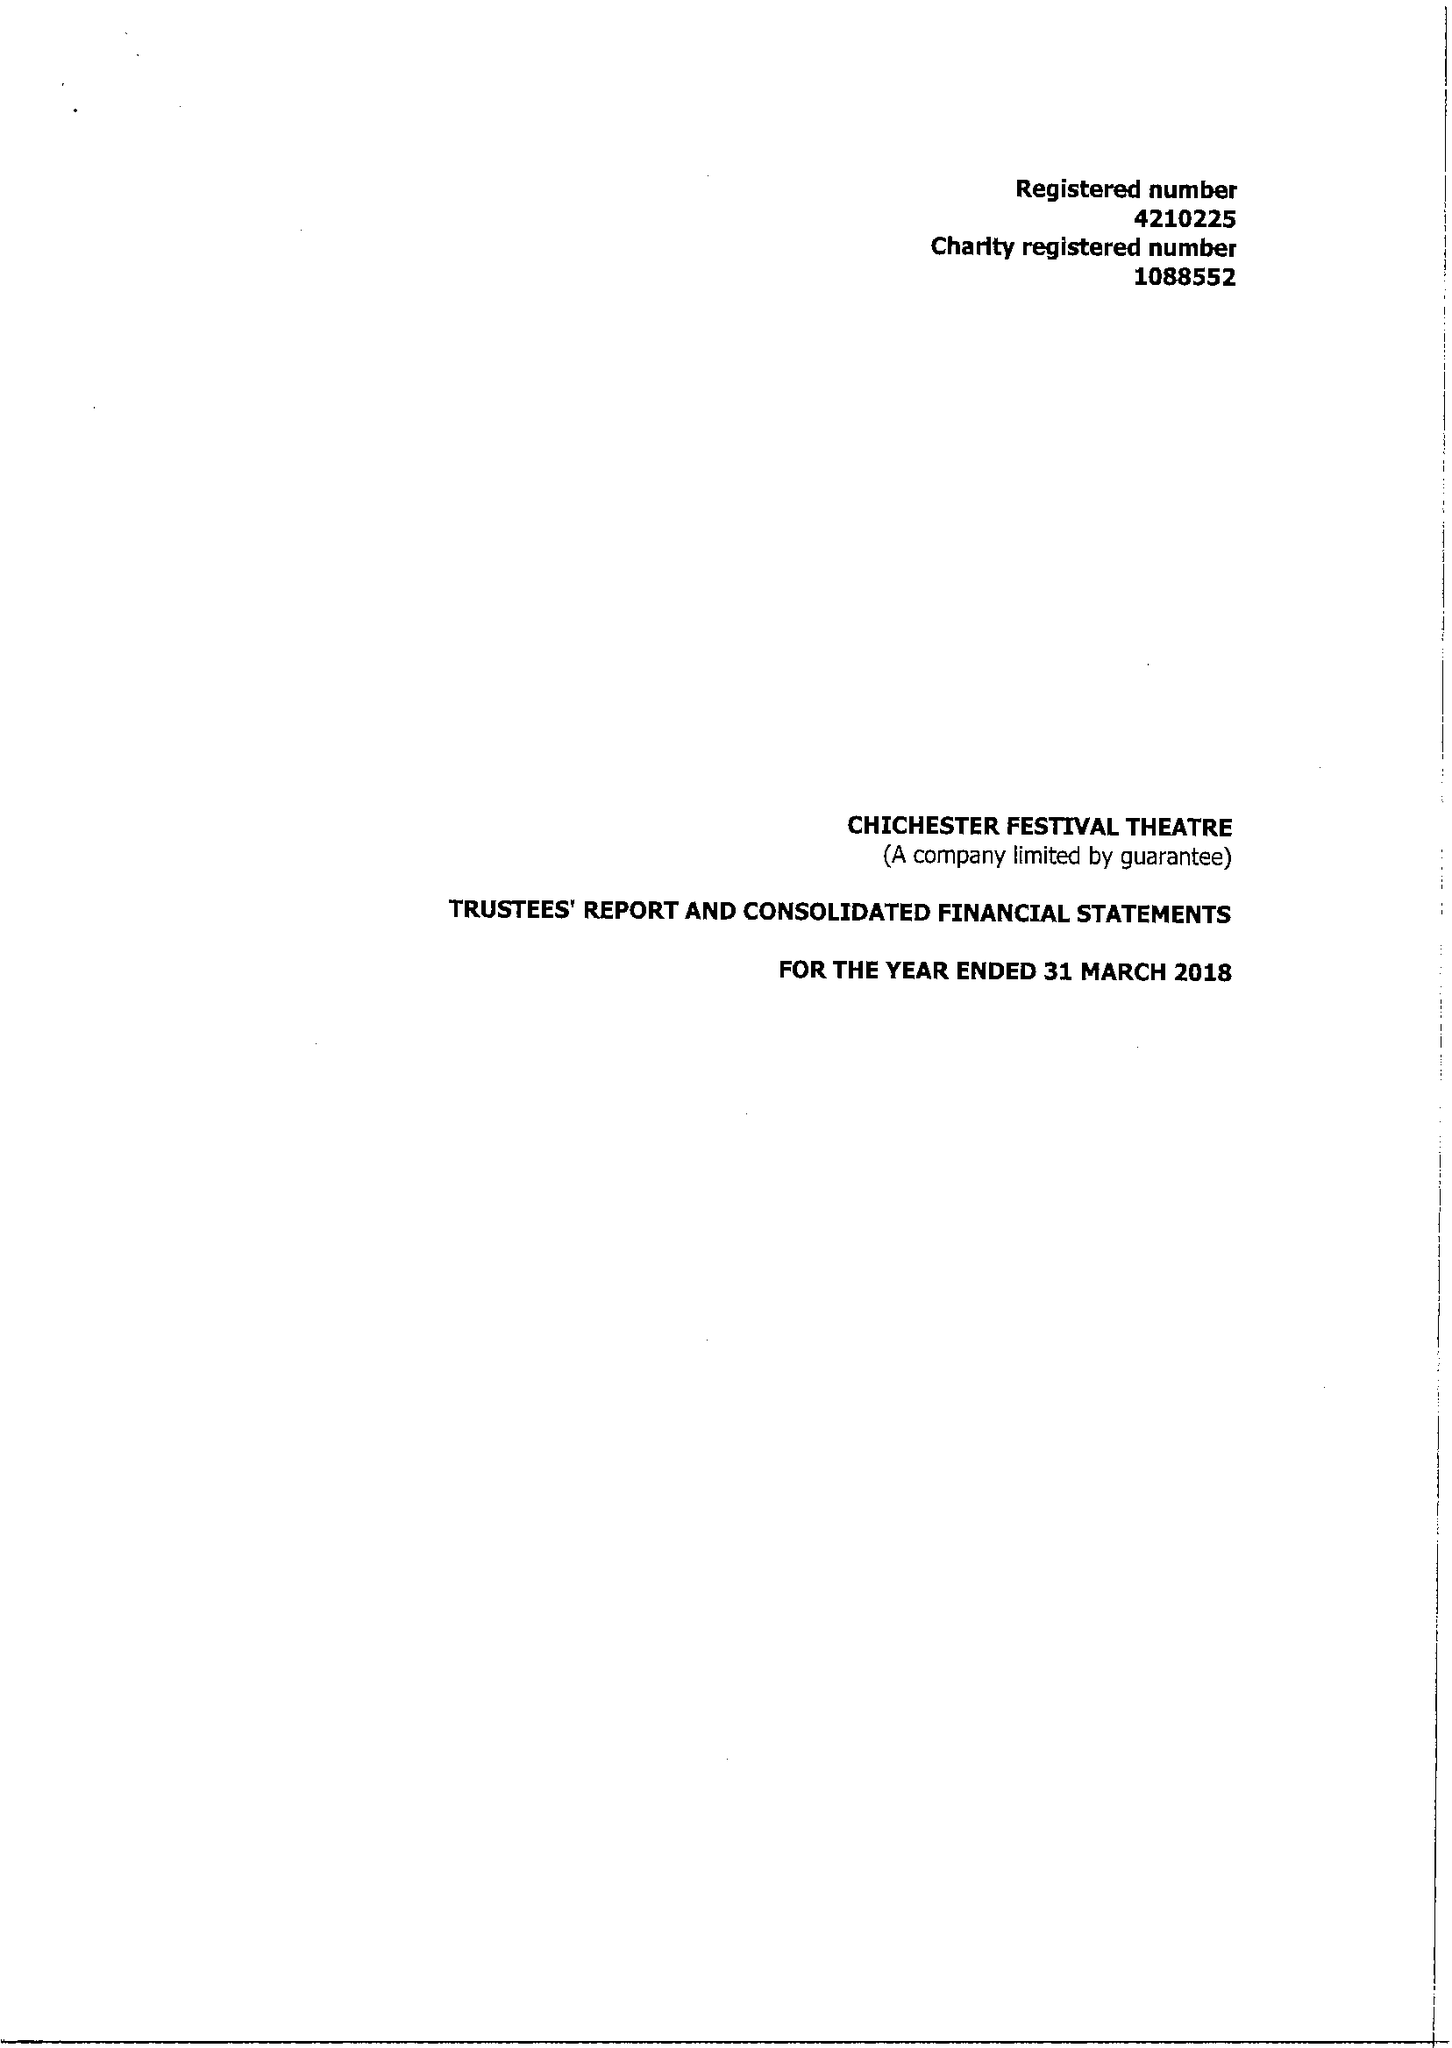What is the value for the charity_number?
Answer the question using a single word or phrase. 1088552 